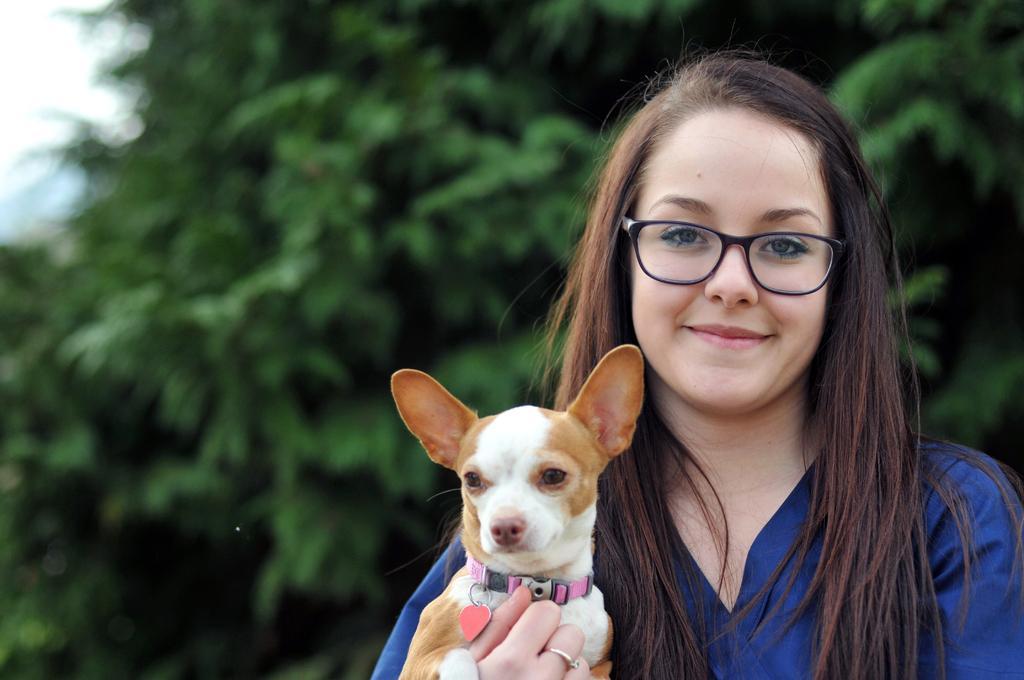In one or two sentences, can you explain what this image depicts? In this picture we can see women wore spectacle and smiling and holding dog with her hands and in background we can see tree. 